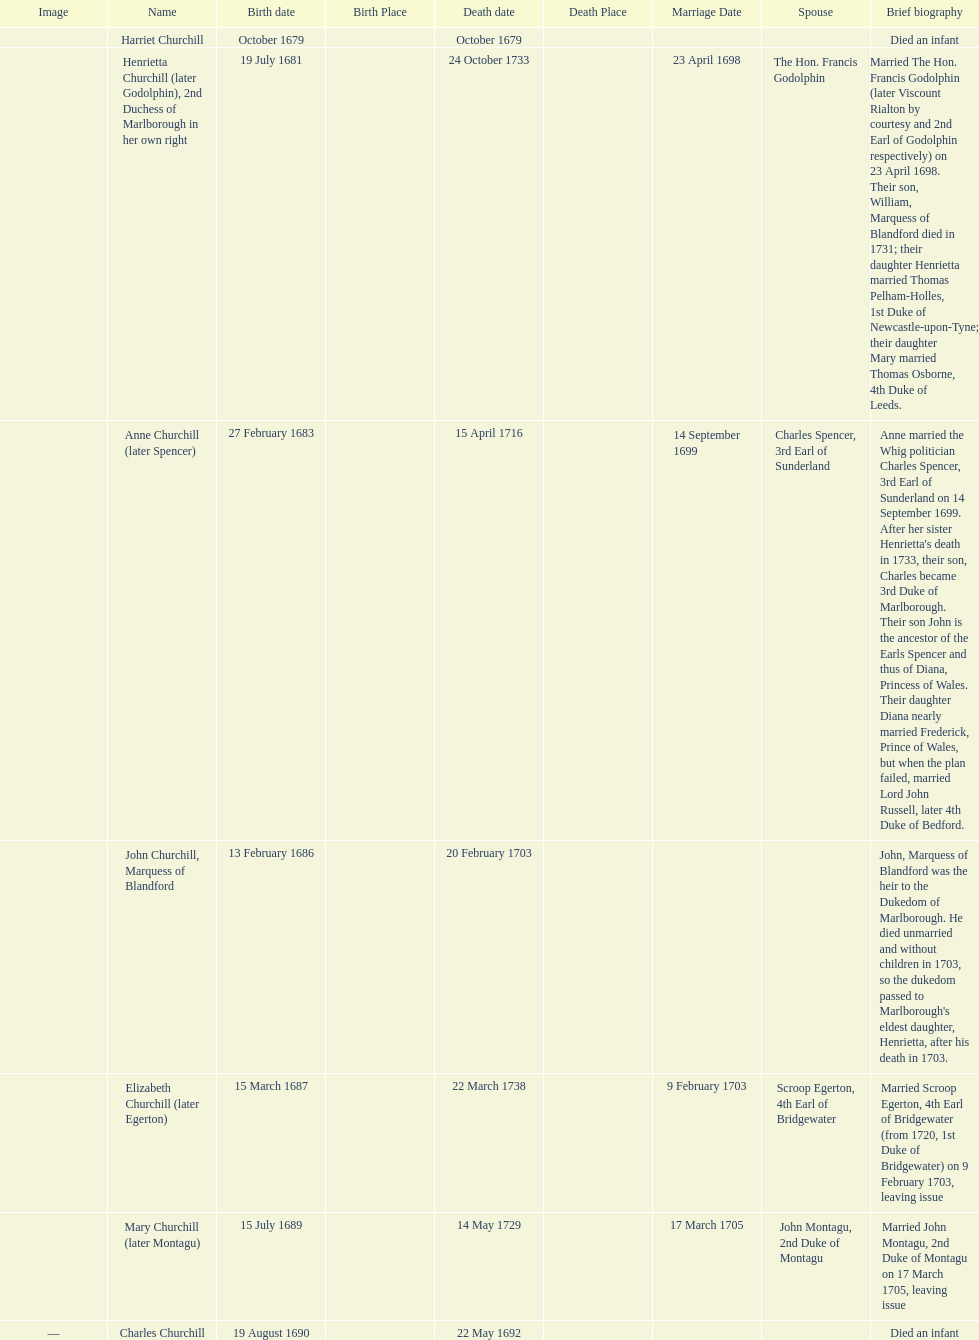Which child was the first to die? Harriet Churchill. 